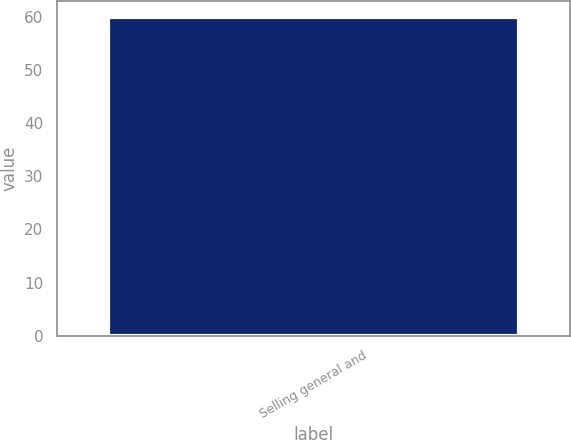Convert chart to OTSL. <chart><loc_0><loc_0><loc_500><loc_500><bar_chart><fcel>Selling general and<nl><fcel>60<nl></chart> 